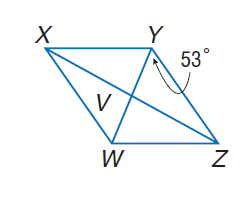Answer the mathemtical geometry problem and directly provide the correct option letter.
Question: Use rhombus X Y Z W with m \angle W Y Z = 53, V W = 3, X V = 2 a - 2, and Z V = \frac { 5 a + 1 } { 4 }. Find m \angle X Y W.
Choices: A: 18 B: 37 C: 53 D: 90 C 